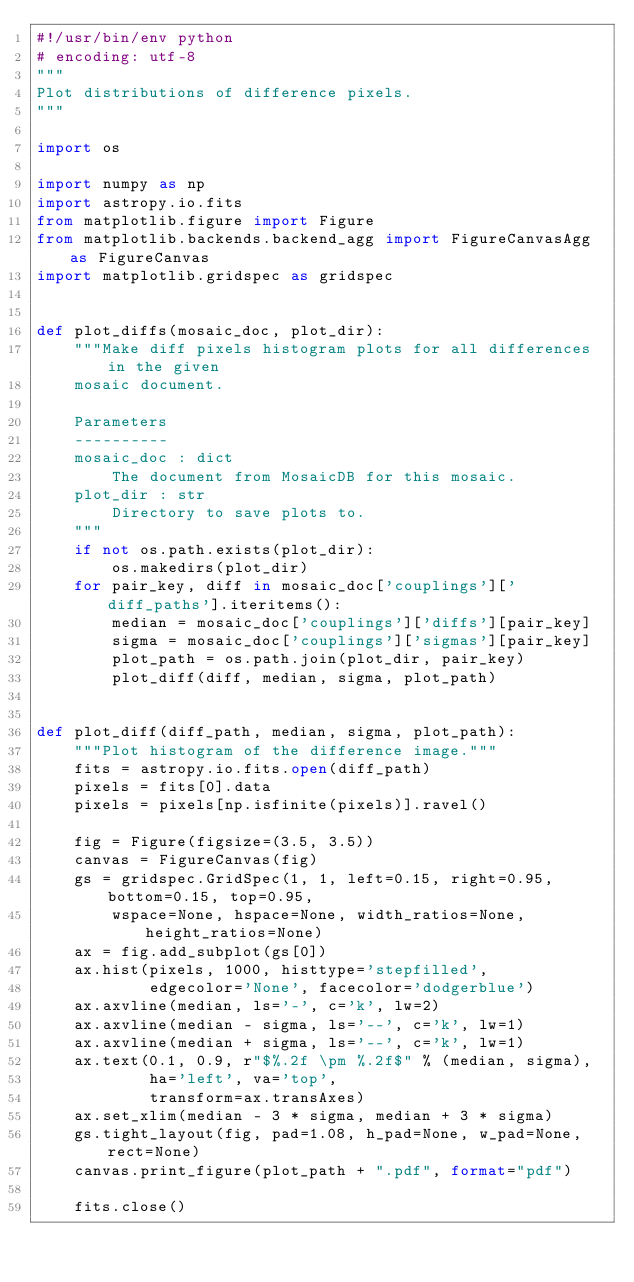Convert code to text. <code><loc_0><loc_0><loc_500><loc_500><_Python_>#!/usr/bin/env python
# encoding: utf-8
"""
Plot distributions of difference pixels.
"""

import os

import numpy as np
import astropy.io.fits
from matplotlib.figure import Figure
from matplotlib.backends.backend_agg import FigureCanvasAgg as FigureCanvas
import matplotlib.gridspec as gridspec


def plot_diffs(mosaic_doc, plot_dir):
    """Make diff pixels histogram plots for all differences in the given
    mosaic document.
    
    Parameters
    ----------
    mosaic_doc : dict
        The document from MosaicDB for this mosaic.
    plot_dir : str
        Directory to save plots to.
    """
    if not os.path.exists(plot_dir):
        os.makedirs(plot_dir)
    for pair_key, diff in mosaic_doc['couplings']['diff_paths'].iteritems():
        median = mosaic_doc['couplings']['diffs'][pair_key]
        sigma = mosaic_doc['couplings']['sigmas'][pair_key]
        plot_path = os.path.join(plot_dir, pair_key)
        plot_diff(diff, median, sigma, plot_path)


def plot_diff(diff_path, median, sigma, plot_path):
    """Plot histogram of the difference image."""
    fits = astropy.io.fits.open(diff_path)
    pixels = fits[0].data
    pixels = pixels[np.isfinite(pixels)].ravel()

    fig = Figure(figsize=(3.5, 3.5))
    canvas = FigureCanvas(fig)
    gs = gridspec.GridSpec(1, 1, left=0.15, right=0.95, bottom=0.15, top=0.95,
        wspace=None, hspace=None, width_ratios=None, height_ratios=None)
    ax = fig.add_subplot(gs[0])
    ax.hist(pixels, 1000, histtype='stepfilled',
            edgecolor='None', facecolor='dodgerblue')
    ax.axvline(median, ls='-', c='k', lw=2)
    ax.axvline(median - sigma, ls='--', c='k', lw=1)
    ax.axvline(median + sigma, ls='--', c='k', lw=1)
    ax.text(0.1, 0.9, r"$%.2f \pm %.2f$" % (median, sigma),
            ha='left', va='top',
            transform=ax.transAxes)
    ax.set_xlim(median - 3 * sigma, median + 3 * sigma)
    gs.tight_layout(fig, pad=1.08, h_pad=None, w_pad=None, rect=None)
    canvas.print_figure(plot_path + ".pdf", format="pdf")

    fits.close()
</code> 